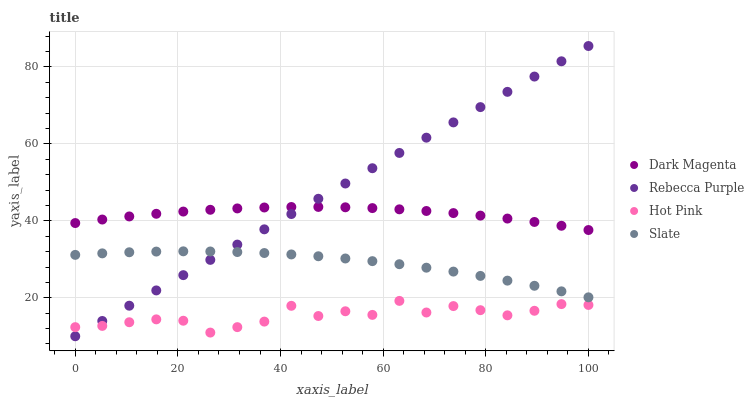Does Hot Pink have the minimum area under the curve?
Answer yes or no. Yes. Does Rebecca Purple have the maximum area under the curve?
Answer yes or no. Yes. Does Dark Magenta have the minimum area under the curve?
Answer yes or no. No. Does Dark Magenta have the maximum area under the curve?
Answer yes or no. No. Is Rebecca Purple the smoothest?
Answer yes or no. Yes. Is Hot Pink the roughest?
Answer yes or no. Yes. Is Dark Magenta the smoothest?
Answer yes or no. No. Is Dark Magenta the roughest?
Answer yes or no. No. Does Rebecca Purple have the lowest value?
Answer yes or no. Yes. Does Hot Pink have the lowest value?
Answer yes or no. No. Does Rebecca Purple have the highest value?
Answer yes or no. Yes. Does Dark Magenta have the highest value?
Answer yes or no. No. Is Hot Pink less than Slate?
Answer yes or no. Yes. Is Slate greater than Hot Pink?
Answer yes or no. Yes. Does Rebecca Purple intersect Dark Magenta?
Answer yes or no. Yes. Is Rebecca Purple less than Dark Magenta?
Answer yes or no. No. Is Rebecca Purple greater than Dark Magenta?
Answer yes or no. No. Does Hot Pink intersect Slate?
Answer yes or no. No. 